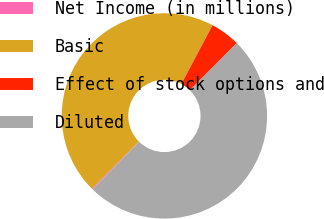Convert chart. <chart><loc_0><loc_0><loc_500><loc_500><pie_chart><fcel>Net Income (in millions)<fcel>Basic<fcel>Effect of stock options and<fcel>Diluted<nl><fcel>0.17%<fcel>45.3%<fcel>4.7%<fcel>49.83%<nl></chart> 